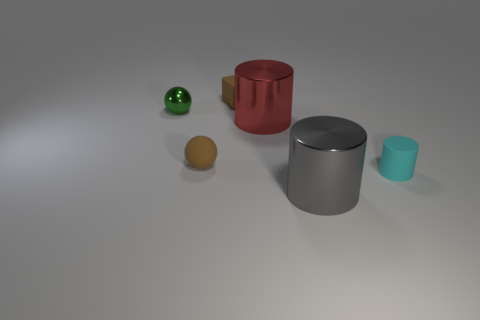Add 3 brown cubes. How many objects exist? 9 Subtract all matte cylinders. How many cylinders are left? 2 Subtract all gray cylinders. How many cylinders are left? 2 Subtract all spheres. How many objects are left? 4 Add 2 large cylinders. How many large cylinders are left? 4 Add 4 small green metallic things. How many small green metallic things exist? 5 Subtract 1 gray cylinders. How many objects are left? 5 Subtract all cyan cubes. Subtract all purple spheres. How many cubes are left? 1 Subtract all tiny brown matte blocks. Subtract all cyan matte things. How many objects are left? 4 